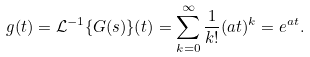<formula> <loc_0><loc_0><loc_500><loc_500>g ( t ) = \mathcal { L } ^ { - 1 } \{ G ( s ) \} ( t ) = \sum _ { k = 0 } ^ { \infty } \frac { 1 } { k ! } ( a t ) ^ { k } = e ^ { a t } .</formula> 